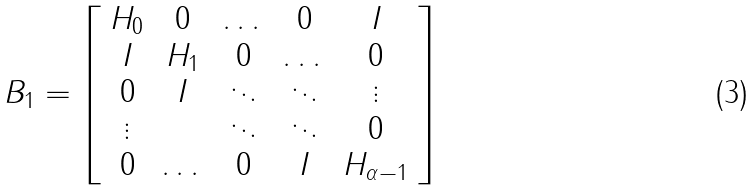<formula> <loc_0><loc_0><loc_500><loc_500>B _ { 1 } = \left [ \begin{array} { c c c c c } H _ { 0 } & 0 & \dots & 0 & I \\ I & H _ { 1 } & 0 & \dots & 0 \\ 0 & I & \ddots & \ddots & \vdots \\ \vdots & & \ddots & \ddots & 0 \\ 0 & \dots & 0 & I & H _ { \alpha - 1 } \\ \end{array} \right ]</formula> 